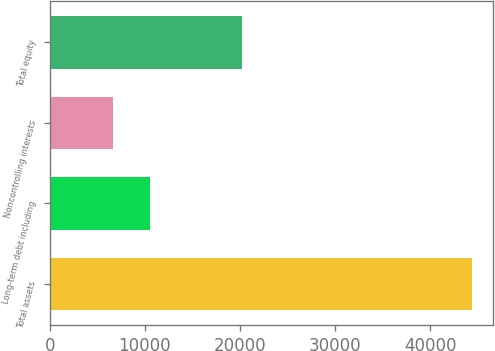<chart> <loc_0><loc_0><loc_500><loc_500><bar_chart><fcel>Total assets<fcel>Long-term debt including<fcel>Noncontrolling interests<fcel>Total equity<nl><fcel>44413<fcel>10572<fcel>6646<fcel>20203<nl></chart> 